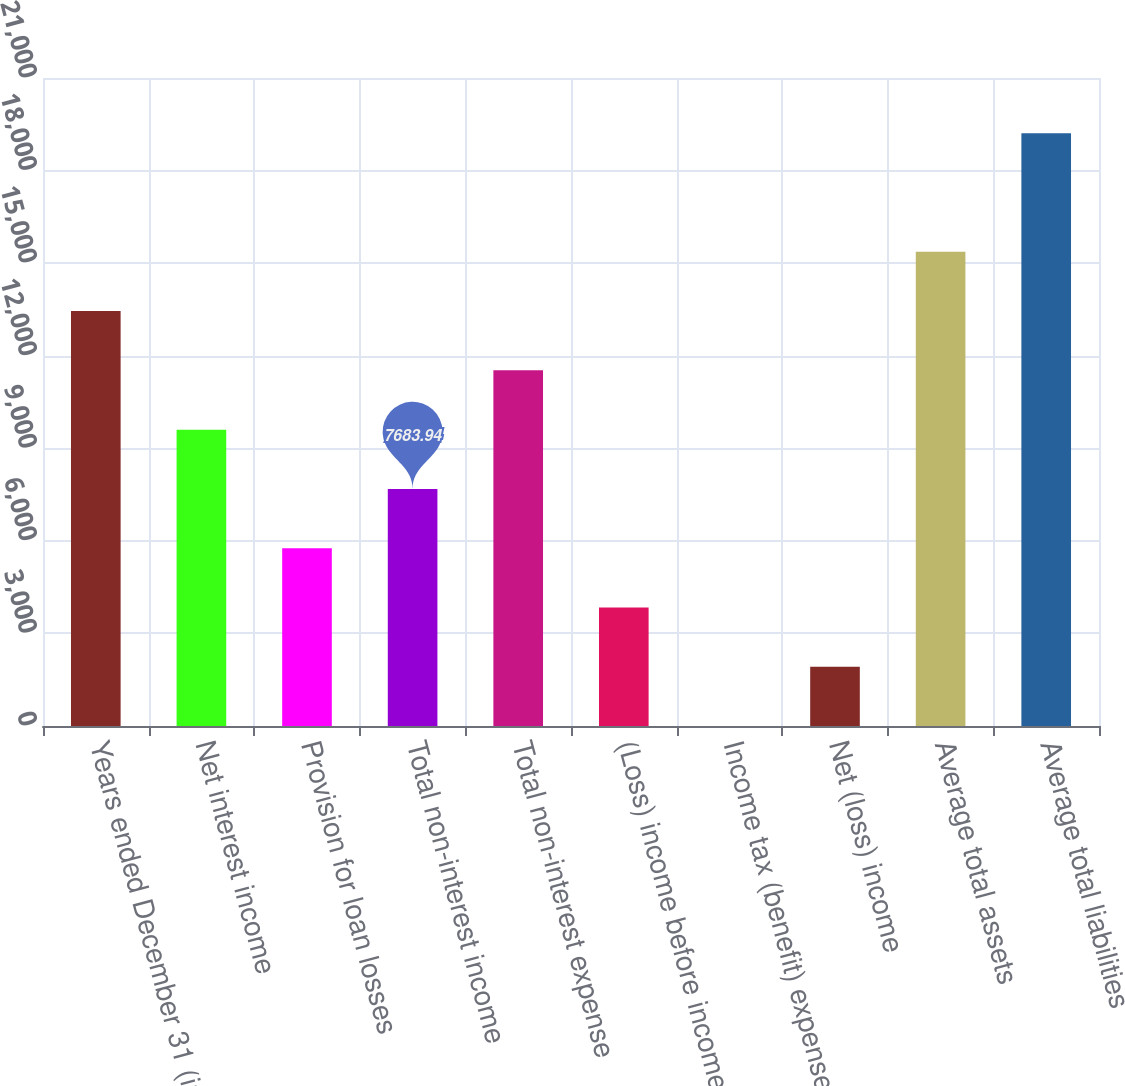Convert chart to OTSL. <chart><loc_0><loc_0><loc_500><loc_500><bar_chart><fcel>Years ended December 31 (in<fcel>Net interest income<fcel>Provision for loan losses<fcel>Total non-interest income<fcel>Total non-interest expense<fcel>(Loss) income before income<fcel>Income tax (benefit) expense<fcel>Net (loss) income<fcel>Average total assets<fcel>Average total liabilities<nl><fcel>13445.6<fcel>9604.5<fcel>5763.38<fcel>7683.94<fcel>11525.1<fcel>3842.82<fcel>1.7<fcel>1922.26<fcel>15366.2<fcel>19207.3<nl></chart> 